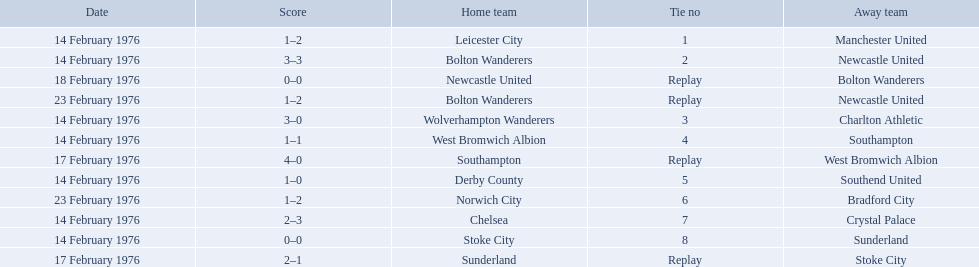What is the game at the top of the table? 1. Who is the home team for this game? Leicester City. 